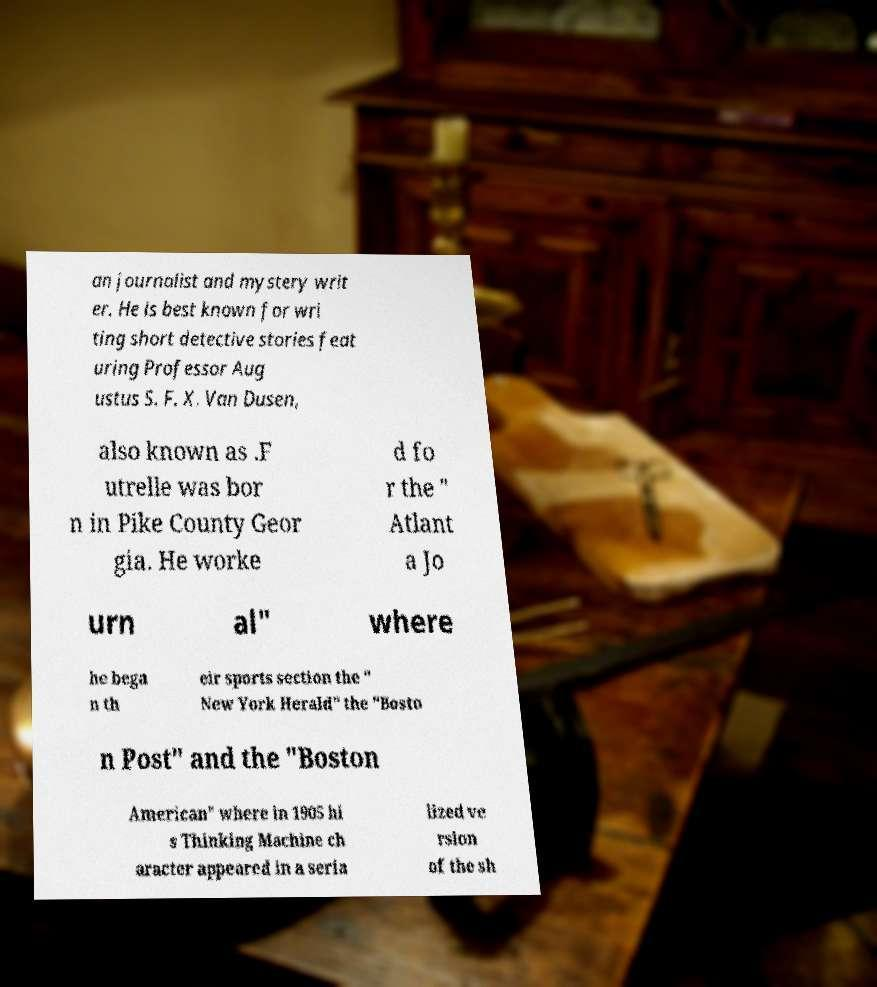Can you read and provide the text displayed in the image?This photo seems to have some interesting text. Can you extract and type it out for me? an journalist and mystery writ er. He is best known for wri ting short detective stories feat uring Professor Aug ustus S. F. X. Van Dusen, also known as .F utrelle was bor n in Pike County Geor gia. He worke d fo r the " Atlant a Jo urn al" where he bega n th eir sports section the " New York Herald" the "Bosto n Post" and the "Boston American" where in 1905 hi s Thinking Machine ch aracter appeared in a seria lized ve rsion of the sh 